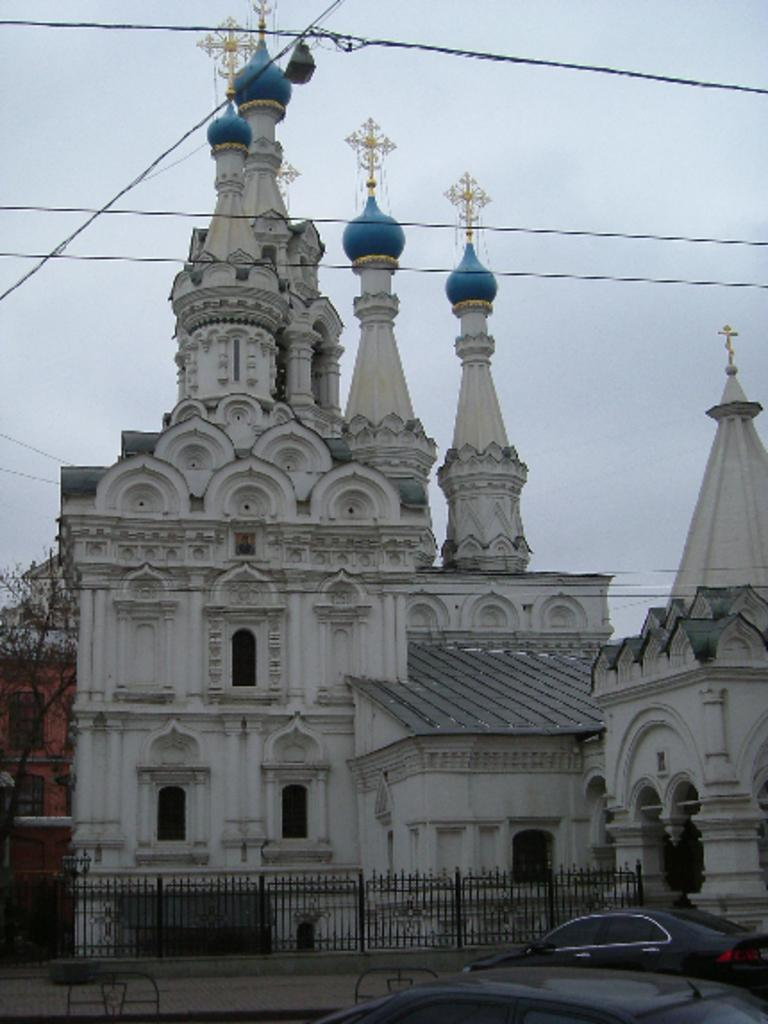What type of structure is depicted in the image? There is a building in the image that resembles a temple. What can be seen at the bottom of the image? Cars are visible at the bottom of the image. What is in the front of the image? There is a fence in the front of the image. What is visible at the top of the image? The sky is visible at the top of the image. How many lamps are hanging from the ceiling of the temple in the image? There is no information about lamps in the image; it only shows a building that resembles a temple, cars, a fence, and the sky. Can you see any geese near the temple in the image? There are no geese present in the image. 